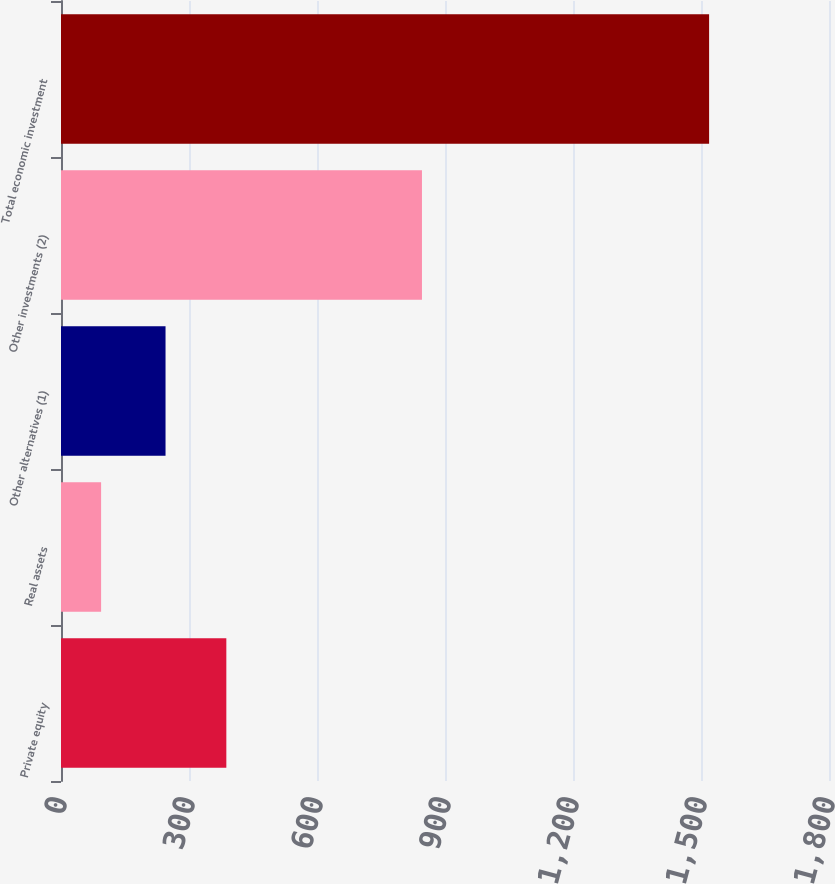<chart> <loc_0><loc_0><loc_500><loc_500><bar_chart><fcel>Private equity<fcel>Real assets<fcel>Other alternatives (1)<fcel>Other investments (2)<fcel>Total economic investment<nl><fcel>387.5<fcel>94<fcel>245<fcel>846<fcel>1519<nl></chart> 